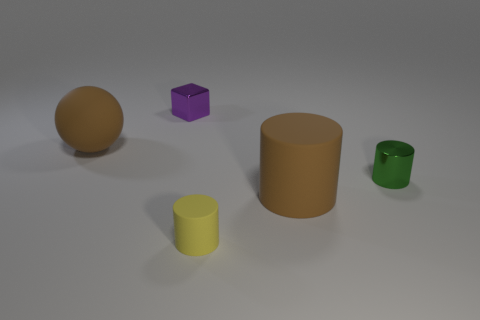There is a thing that is the same color as the big matte cylinder; what material is it?
Offer a terse response. Rubber. Is there any other thing that is the same size as the yellow object?
Provide a short and direct response. Yes. Is there any other thing that has the same shape as the yellow matte object?
Offer a very short reply. Yes. Is the number of big brown matte spheres to the right of the yellow matte cylinder greater than the number of tiny cubes in front of the tiny metallic cylinder?
Provide a succinct answer. No. What size is the brown thing behind the big object on the right side of the object that is behind the brown rubber ball?
Give a very brief answer. Large. Are the large cylinder and the object behind the large brown rubber ball made of the same material?
Your response must be concise. No. Is the shape of the small green shiny object the same as the small purple object?
Keep it short and to the point. No. What number of other things are there of the same material as the tiny green cylinder
Ensure brevity in your answer.  1. How many small green shiny objects are the same shape as the small purple object?
Your answer should be compact. 0. What color is the tiny object that is in front of the tiny purple object and to the left of the metal cylinder?
Offer a terse response. Yellow. 